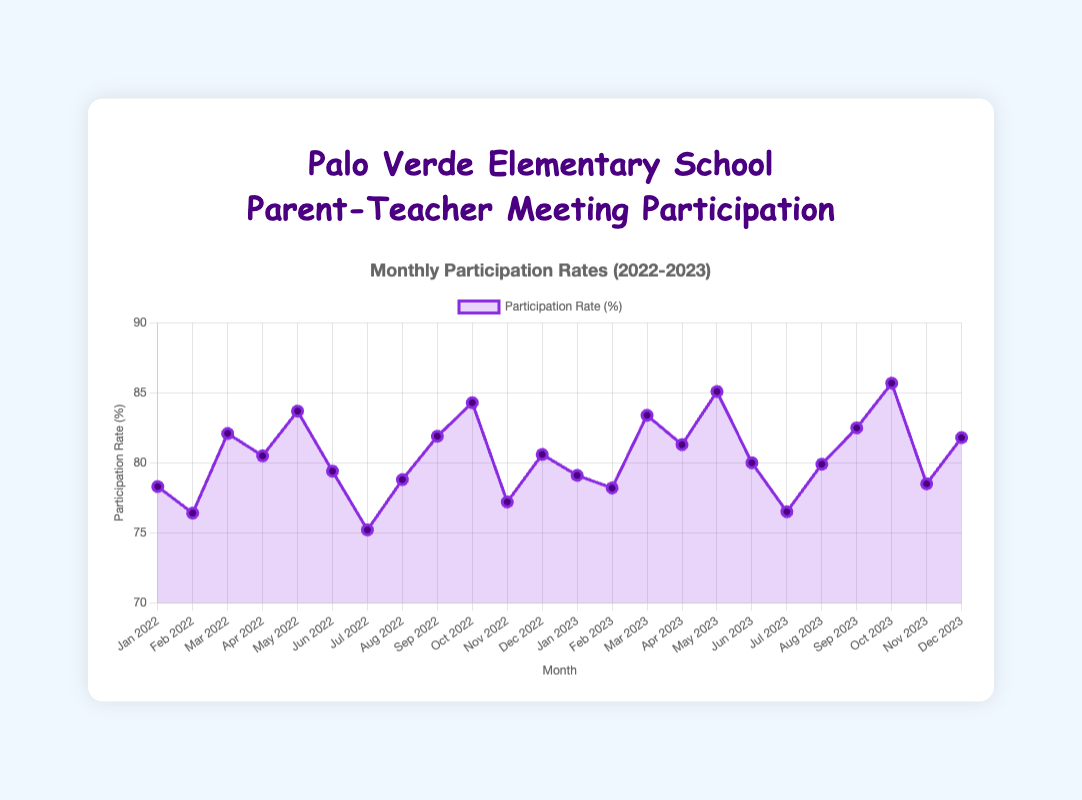What was the participation rate in May 2023? Look at the point marked for May 2023 on the X-axis and read the corresponding Y-axis value. The participation rate is 85.1%
Answer: 85.1% Which month had the lowest participation rate in 2022? Scan through the points for each month in 2022 and identify the lowest value. The lowest participation rate in 2022 was in July with 75.2%
Answer: July In which month of 2023 did the participation rate first exceed 80%? Look at the data points from January 2023 onwards and identify the first month when the Y-axis value exceeds 80%. The participation rate first exceeded 80% in March 2023
Answer: March What is the average participation rate for the first three months of 2022? The participation rates are 78.3%, 76.4%, and 82.1%. Calculate the average: (78.3 + 76.4 + 82.1) / 3 = 78.93
Answer: 78.93 How does the participation rate in December 2023 compare with December 2022? Look at the data points for December in both years. The rate in December 2023 (81.8%) is higher than in December 2022 (80.6%)
Answer: December 2023 is higher Which month in 2023 saw the highest participation rate? Look at all the data points for 2023 and identify the highest value. The highest participation rate in 2023 was in October with 85.7%
Answer: October Did the participation rate increase or decrease from April 2022 to May 2022? Compare the data points for April and May 2022. The participation rate increased from 80.5% to 83.7%
Answer: Increased What is the difference in participation rates between October 2022 and October 2023? Subtract the October 2022 rate from the October 2023 rate: 85.7% - 84.3% = 1.4%
Answer: 1.4% How many months in 2022 had a participation rate greater than 80%? Identify and count the months with rates above 80%: March, April, May, September, and October (5 months)
Answer: 5 months 